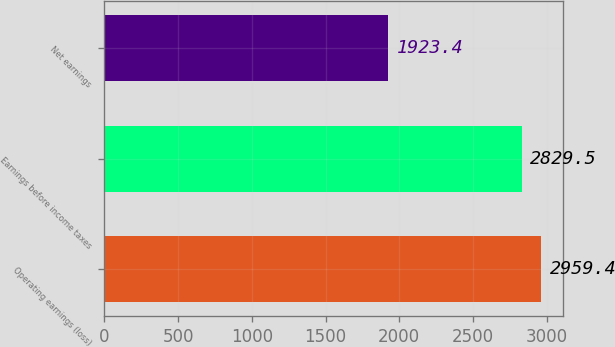Convert chart to OTSL. <chart><loc_0><loc_0><loc_500><loc_500><bar_chart><fcel>Operating earnings (loss)<fcel>Earnings before income taxes<fcel>Net earnings<nl><fcel>2959.4<fcel>2829.5<fcel>1923.4<nl></chart> 